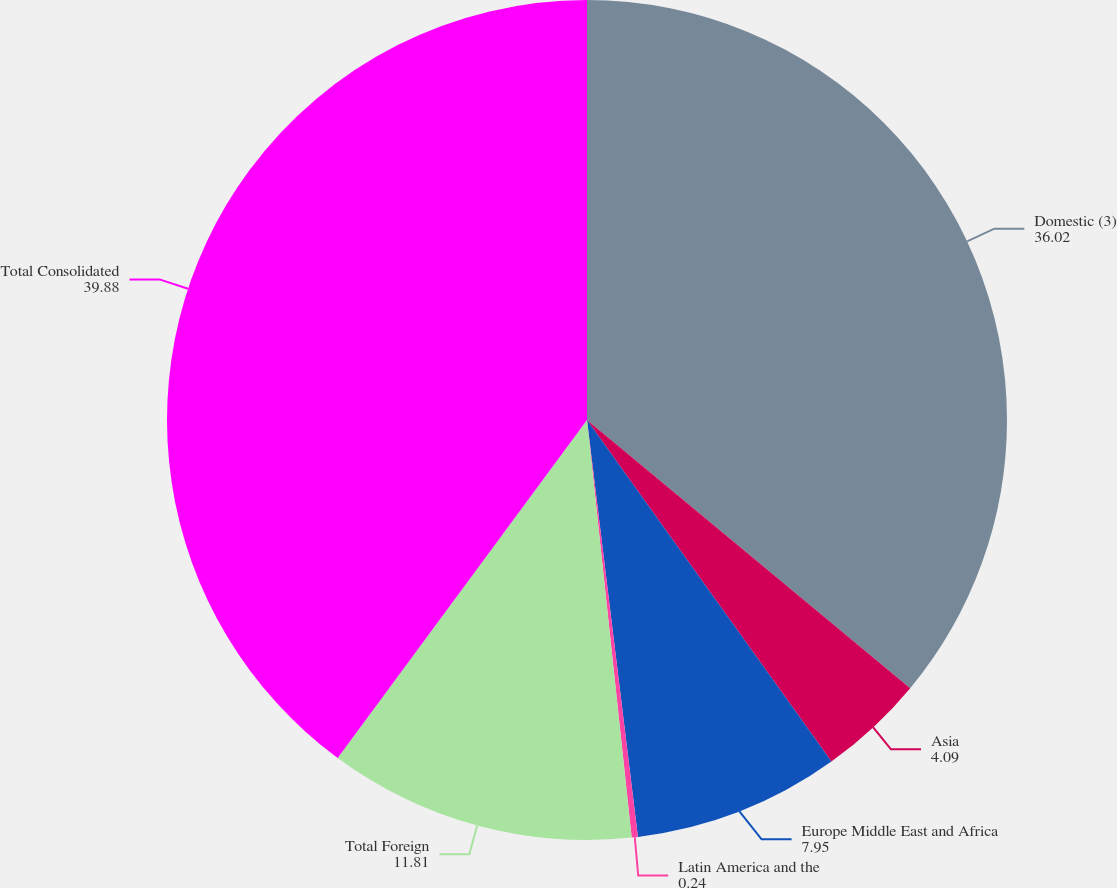Convert chart. <chart><loc_0><loc_0><loc_500><loc_500><pie_chart><fcel>Domestic (3)<fcel>Asia<fcel>Europe Middle East and Africa<fcel>Latin America and the<fcel>Total Foreign<fcel>Total Consolidated<nl><fcel>36.02%<fcel>4.09%<fcel>7.95%<fcel>0.24%<fcel>11.81%<fcel>39.88%<nl></chart> 